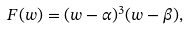Convert formula to latex. <formula><loc_0><loc_0><loc_500><loc_500>F ( w ) = ( w - \alpha ) ^ { 3 } ( w - \beta ) ,</formula> 